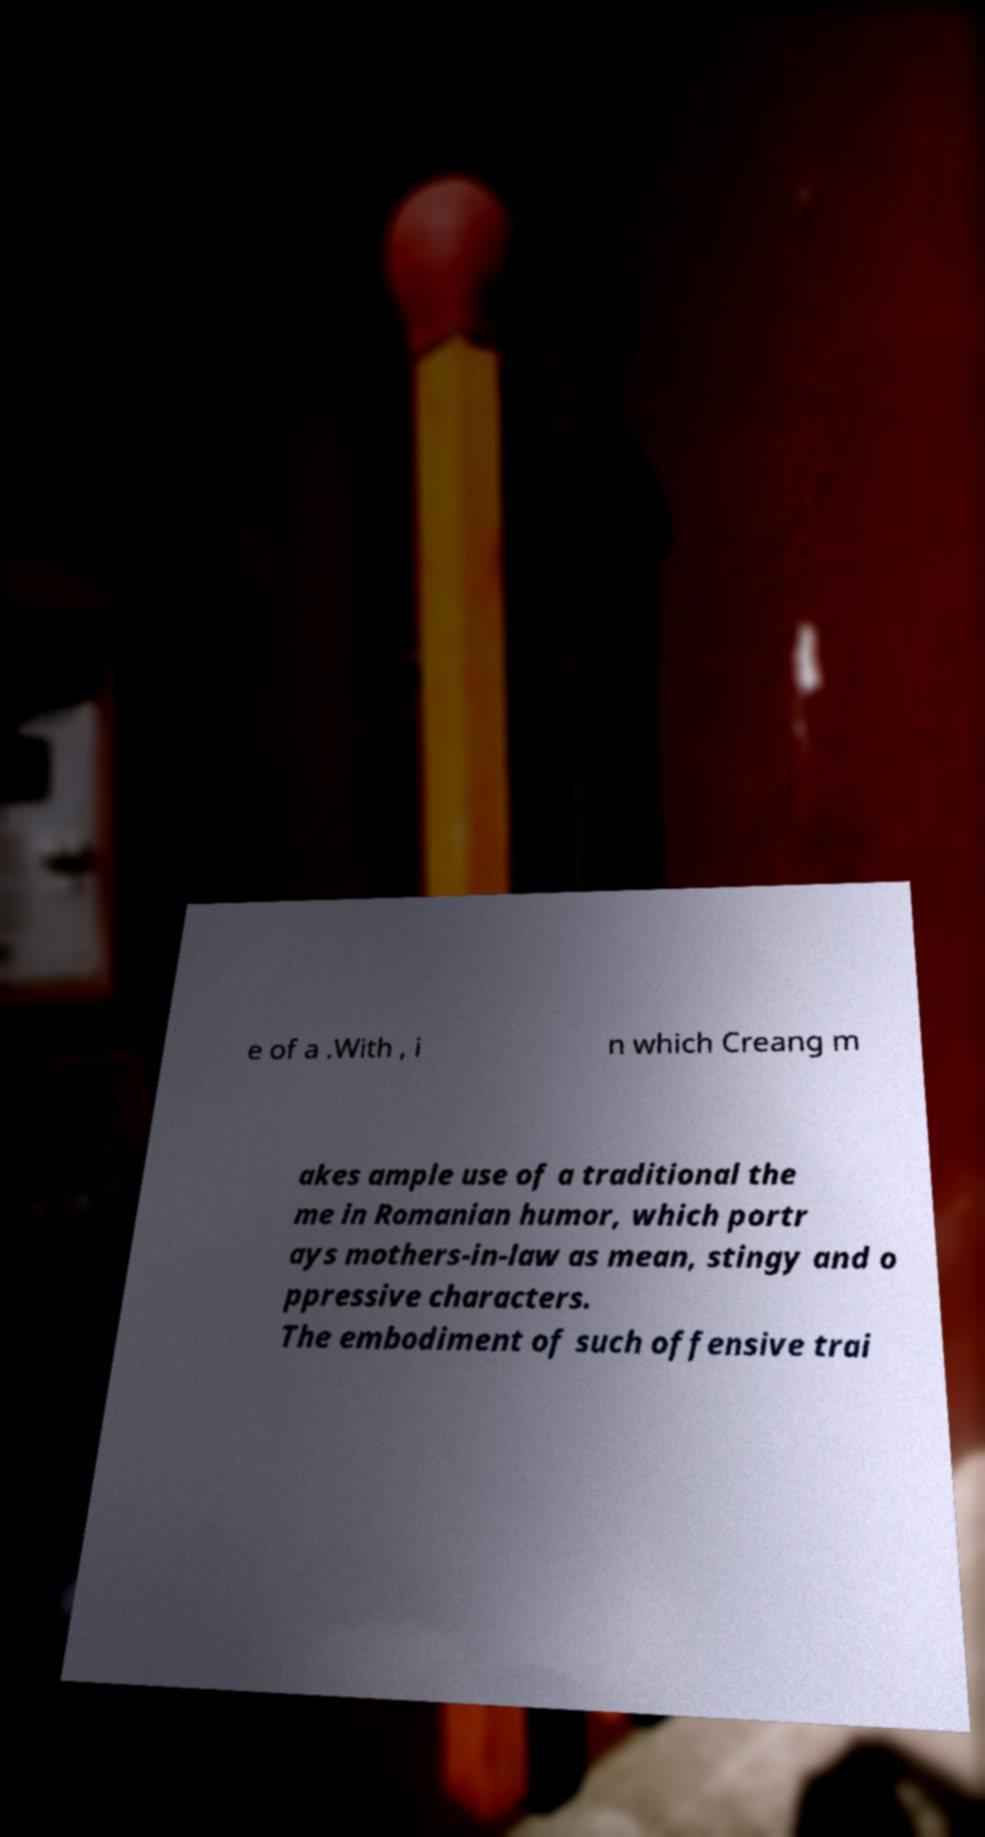I need the written content from this picture converted into text. Can you do that? e of a .With , i n which Creang m akes ample use of a traditional the me in Romanian humor, which portr ays mothers-in-law as mean, stingy and o ppressive characters. The embodiment of such offensive trai 